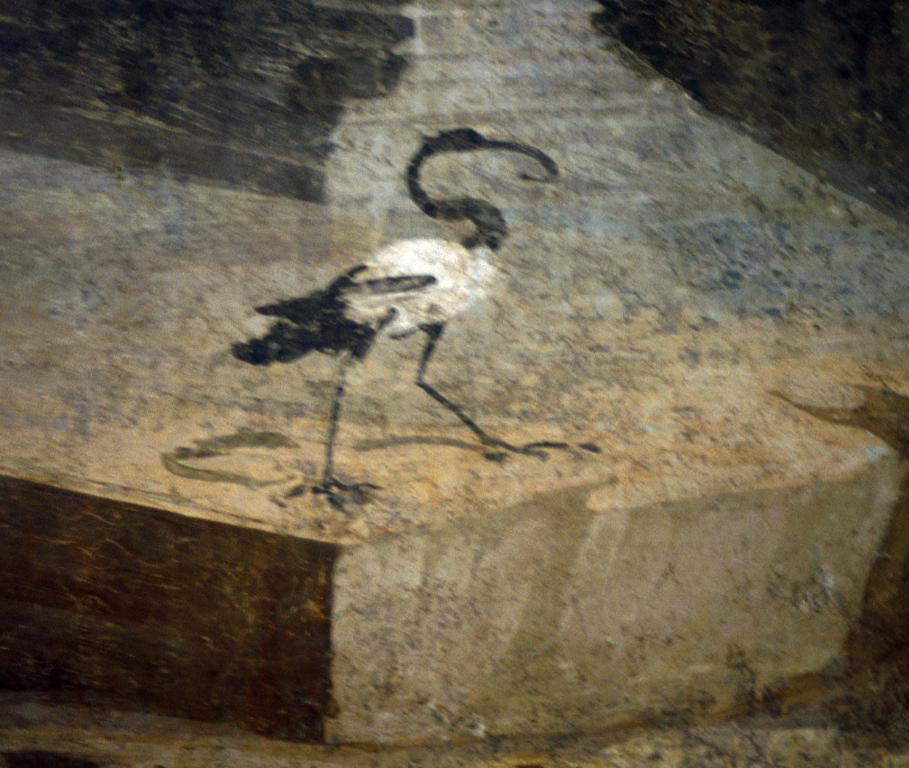What type of artwork is depicted in the image? The image is a painting. What animal can be seen in the painting? There is a crane in the painting. What does your dad think about the painting? The provided facts do not mention anything about the opinion of the person's dad, so we cannot answer this question. 